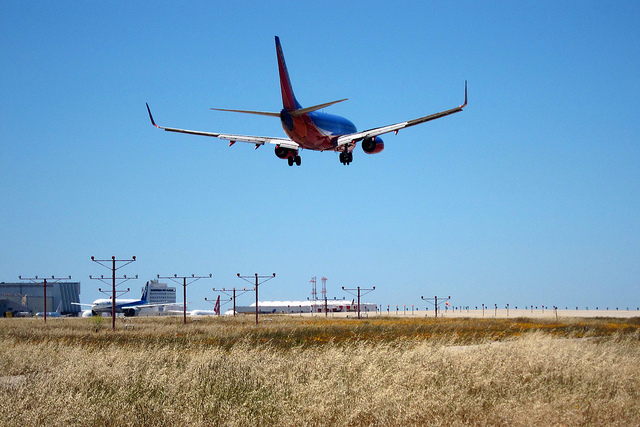<image>How many people are in the plane? I don't know how many people are in the plane. The number of people is not specified. How many people are in the plane? I am not sure how many people are in the plane. It can be seen 2, 108, 0, 50, 100 or 150. 